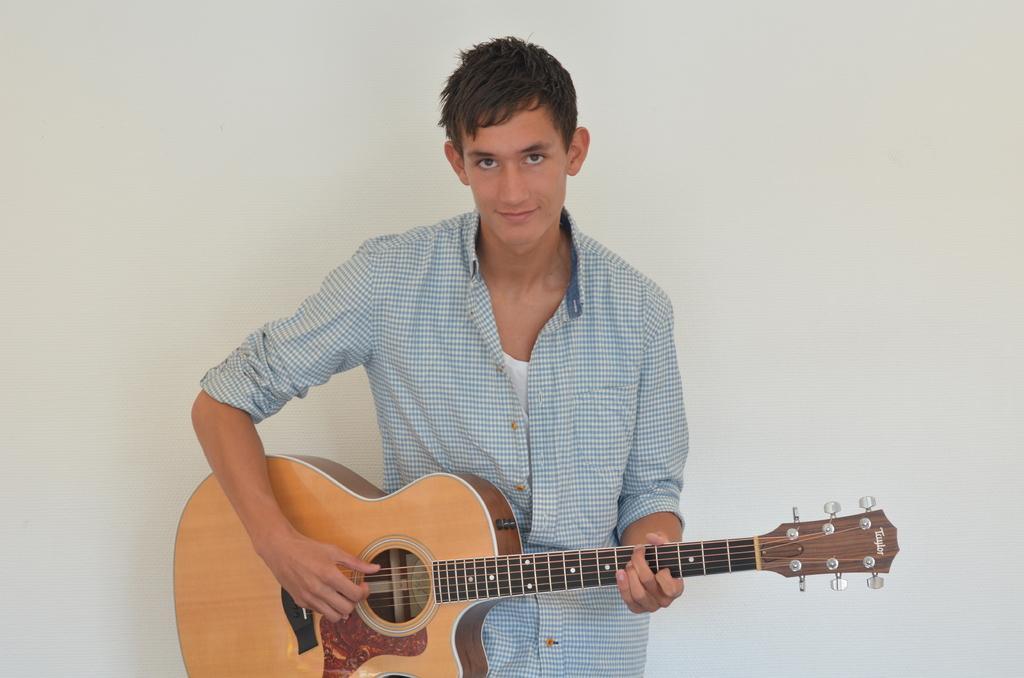Could you give a brief overview of what you see in this image? The image consists of a boy wearing a checked shirt playing a guitar. 